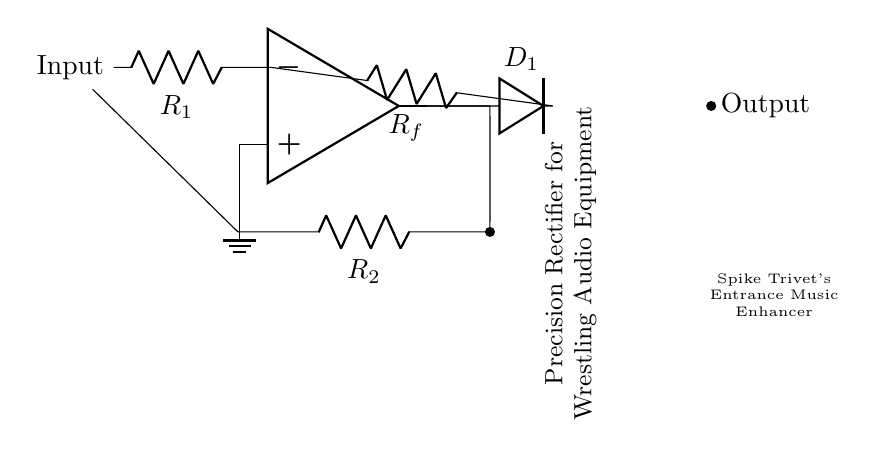What is the primary function of this circuit? The circuit is a precision rectifier, which converts alternating current (AC) signals into direct current (DC) signals. This is needed for accurate signal processing in audio applications.
Answer: Precision rectifier What components are used in the circuit? The circuit consists of an operational amplifier, resistor R1, diode D1, feedback resistor Rf, and resistor R2. Each component serves a specific function in rectifying the input signal.
Answer: Operational amplifier, R1, D1, Rf, R2 How many resistors are present in the circuit? There are three resistors: R1, Rf, and R2. Counting the components directly from the diagram yields a total of three resistors.
Answer: Three What is the role of the diode in the circuit? The diode D1 allows current to flow in only one direction, enabling the rectification process by blocking reverse polarity, which is essential for producing a proper DC output.
Answer: Blocking reverse polarity What does "Spike Trivet's Entrance Music Enhancer" refer to? This labeling suggests that the circuit is specifically designed to enhance the audio quality or features of Spike Trivet's entrance music, likely by ensuring clean and accurate signal rectification.
Answer: Audio quality enhancement What is the connection type between R2 and the input? The connection type between R2 and the input is a feedback short; it connects directly from the op-amp output back to the input side. This feedback loop is crucial for stabilizing the operational amplifier's response.
Answer: Feedback short Why is an operational amplifier used in this rectifier circuit? The operational amplifier is crucial for amplifying the input signal and ensuring that the rectification occurs accurately. It enhances the circuit's performance by providing high input impedance and low output impedance.
Answer: Amplification and accuracy 